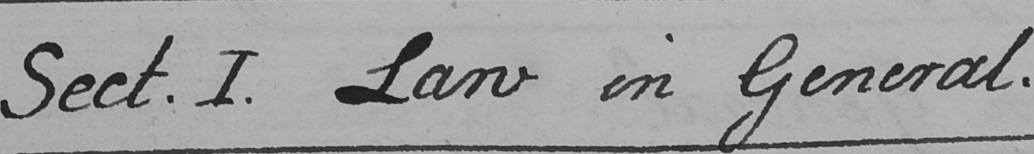What does this handwritten line say? Sect . I . Law in General . 